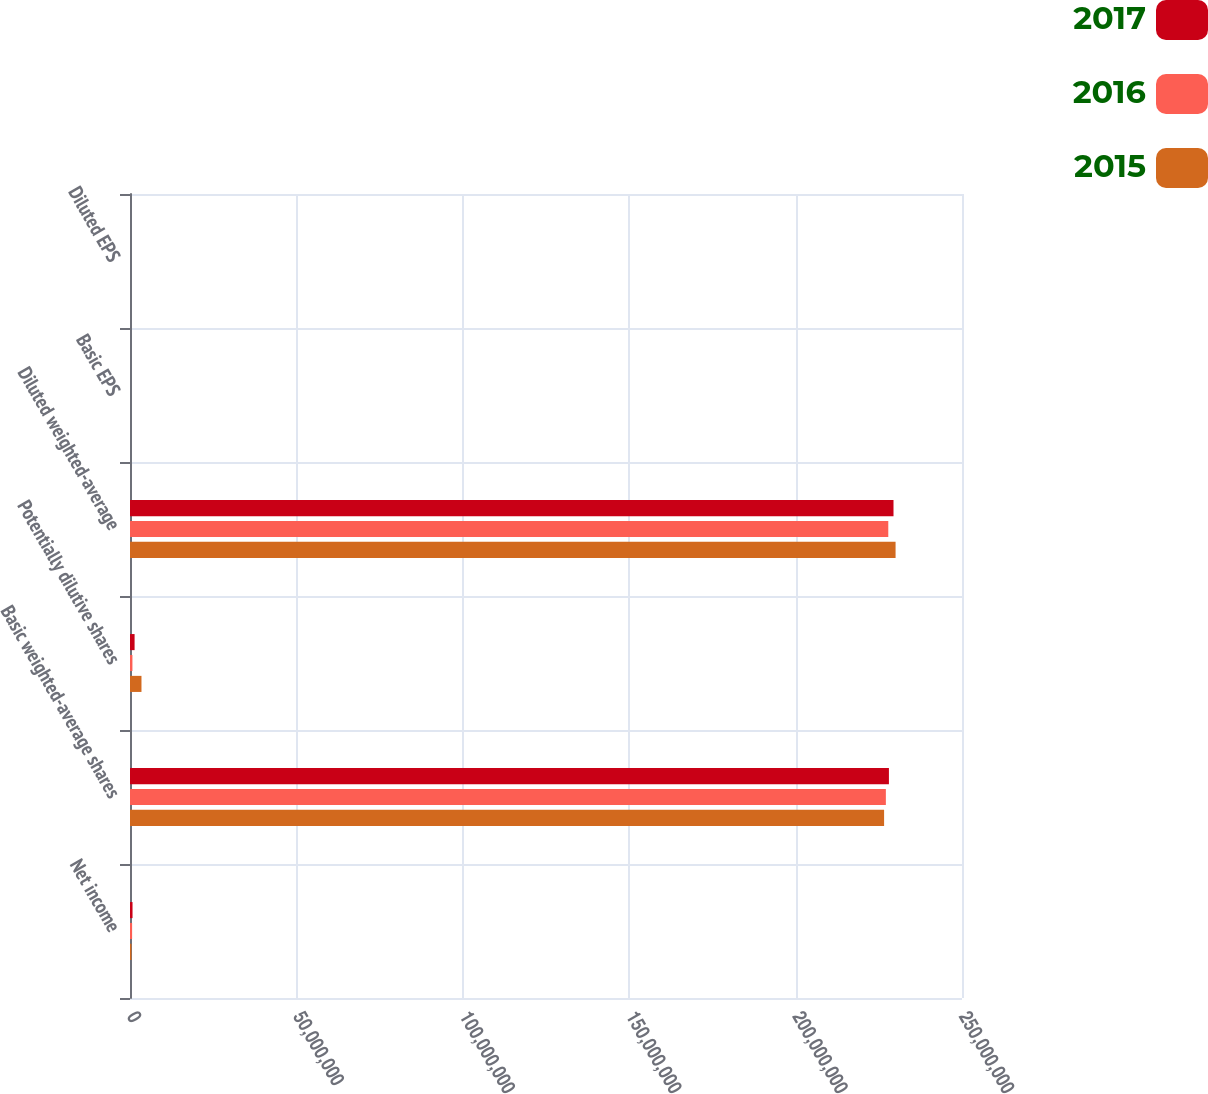Convert chart to OTSL. <chart><loc_0><loc_0><loc_500><loc_500><stacked_bar_chart><ecel><fcel>Net income<fcel>Basic weighted-average shares<fcel>Potentially dilutive shares<fcel>Diluted weighted-average<fcel>Basic EPS<fcel>Diluted EPS<nl><fcel>2017<fcel>759872<fcel>2.28041e+08<fcel>1.3775e+06<fcel>2.29418e+08<fcel>3.33<fcel>3.31<nl><fcel>2016<fcel>633085<fcel>2.27122e+08<fcel>728411<fcel>2.2785e+08<fcel>2.79<fcel>2.78<nl><fcel>2015<fcel>427137<fcel>2.26591e+08<fcel>3.4487e+06<fcel>2.3004e+08<fcel>1.89<fcel>1.86<nl></chart> 